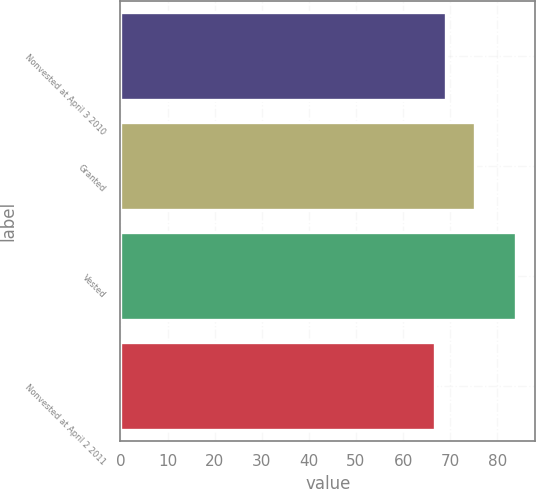<chart> <loc_0><loc_0><loc_500><loc_500><bar_chart><fcel>Nonvested at April 3 2010<fcel>Granted<fcel>Vested<fcel>Nonvested at April 2 2011<nl><fcel>69.09<fcel>75.29<fcel>83.85<fcel>66.78<nl></chart> 